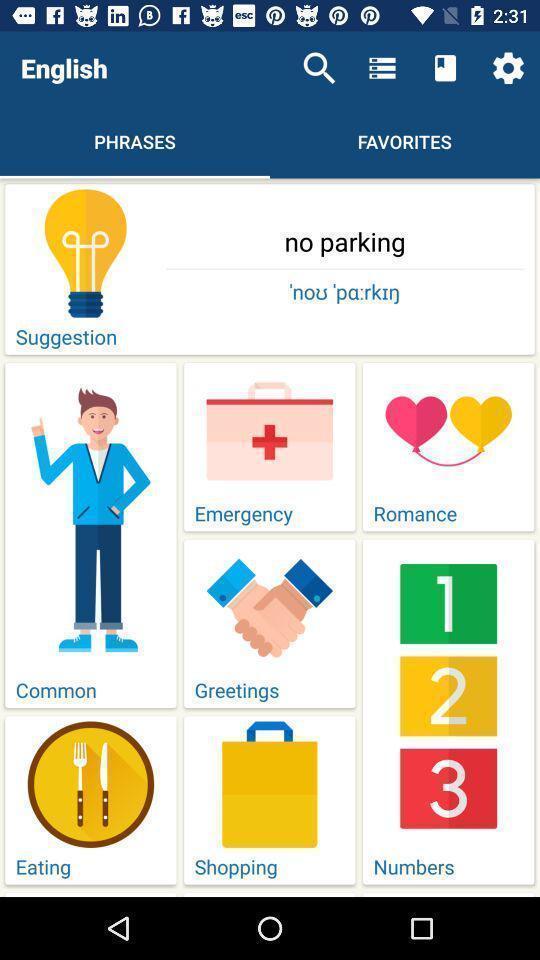Describe the key features of this screenshot. Page displaying with different options for phrases tab. 